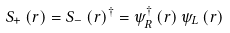<formula> <loc_0><loc_0><loc_500><loc_500>S _ { + } \left ( { r } \right ) = S _ { - } \left ( { r } \right ) ^ { \dag } = \psi _ { R } ^ { \dag } \left ( { r } \right ) \psi _ { L } \left ( { r } \right )</formula> 